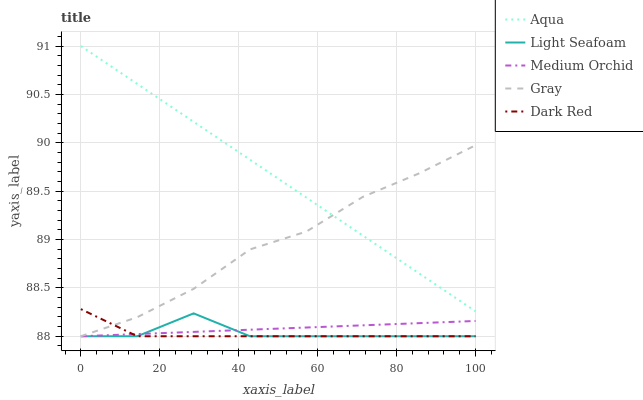Does Dark Red have the minimum area under the curve?
Answer yes or no. Yes. Does Aqua have the maximum area under the curve?
Answer yes or no. Yes. Does Medium Orchid have the minimum area under the curve?
Answer yes or no. No. Does Medium Orchid have the maximum area under the curve?
Answer yes or no. No. Is Aqua the smoothest?
Answer yes or no. Yes. Is Light Seafoam the roughest?
Answer yes or no. Yes. Is Medium Orchid the smoothest?
Answer yes or no. No. Is Medium Orchid the roughest?
Answer yes or no. No. Does Gray have the lowest value?
Answer yes or no. Yes. Does Aqua have the lowest value?
Answer yes or no. No. Does Aqua have the highest value?
Answer yes or no. Yes. Does Light Seafoam have the highest value?
Answer yes or no. No. Is Light Seafoam less than Aqua?
Answer yes or no. Yes. Is Aqua greater than Medium Orchid?
Answer yes or no. Yes. Does Light Seafoam intersect Dark Red?
Answer yes or no. Yes. Is Light Seafoam less than Dark Red?
Answer yes or no. No. Is Light Seafoam greater than Dark Red?
Answer yes or no. No. Does Light Seafoam intersect Aqua?
Answer yes or no. No. 